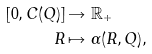<formula> <loc_0><loc_0><loc_500><loc_500>[ 0 , C ( Q ) ] & \rightarrow { \mathbb { R } } _ { + } \\ R & \mapsto \alpha ( R , Q ) ,</formula> 